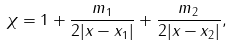<formula> <loc_0><loc_0><loc_500><loc_500>\chi = 1 + \frac { m _ { 1 } } { 2 | x - x _ { 1 } | } + \frac { m _ { 2 } } { 2 | x - x _ { 2 } | } ,</formula> 